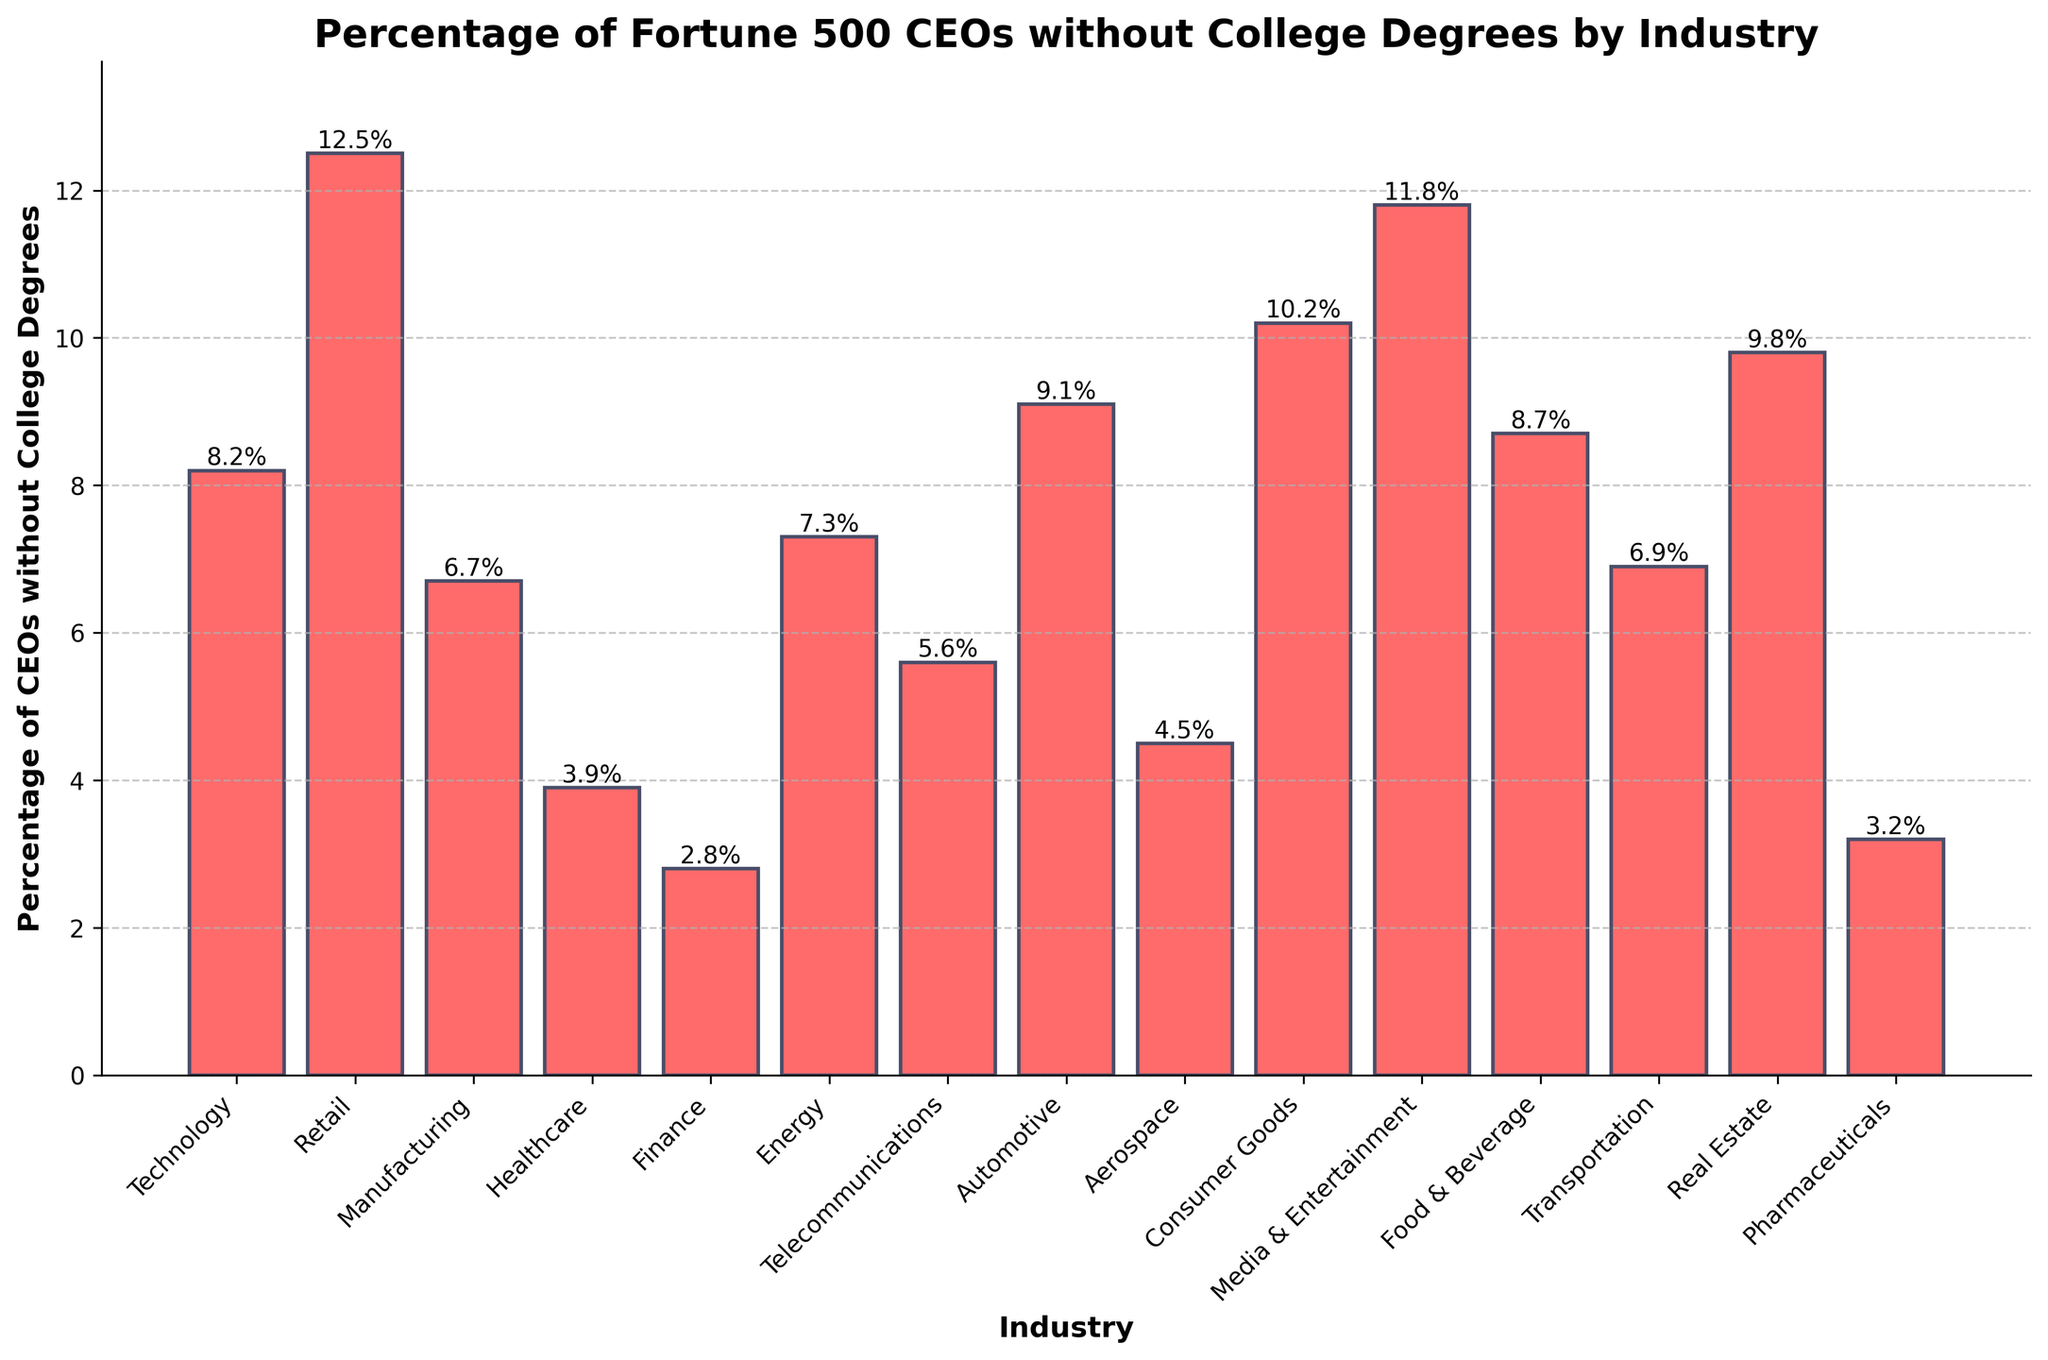What is the industry with the highest percentage of Fortune 500 CEOs without college degrees? The industry with the highest bar represents the industry with the highest percentage. By looking at the height of the bars, Retail has the highest percentage.
Answer: Retail Which industry has the lowest percentage of Fortune 500 CEOs without college degrees? The industry with the lowest bar represents the industry with the lowest percentage. The Finance industry has the lowest percentage.
Answer: Finance What is the percentage point difference between the Technology and Media & Entertainment industries regarding CEOs without college degrees? The percentage for Technology is 8.2%, and for Media & Entertainment, it is 11.8%. Subtract 8.2% from 11.8% to get the difference. 11.8% - 8.2% = 3.6%.
Answer: 3.6% Which industries have more than 10% of Fortune 500 CEOs without college degrees? Identify and list the industries with bars exceeding the 10% mark. From the graph, Media & Entertainment, Retail, Consumer Goods, and Real Estate exceed 10%.
Answer: Media & Entertainment, Retail, Consumer Goods, Real Estate Are there more industries above or below 7% in terms of the percentage of CEOs without college degrees? Count the number of industries with percentages above 7% and below 7%. There are 8 industries above 7% (Technology, Retail, Manufacturing, Energy, Automotive, Consumer Goods, Media & Entertainment, Food & Beverage) and 7 industries below 7% (Healthcare, Finance, Telecommunications, Aerospace, Transportation, Real Estate, Pharmaceuticals).
Answer: Above 7% Does the Consumer Goods industry have a higher or lower percentage of Fortune 500 CEOs without college degrees compared to the Automotive industry? Compare the bar heights of Consumer Goods (10.2%) and Automotive (9.1%). Consumer Goods has a higher percentage.
Answer: Higher Which three industries have the closest percentages of CEOs without college degrees and what are those percentages? Identify the industries with the closest bar heights. Transportation (6.9%), Energy (7.3%), and Technology (8.2%) have closely ranged percentages.
Answer: Transportation: 6.9%, Energy: 7.3%, Technology: 8.2% How much higher is the percentage of CEOs without college degrees in Retail compared to Pharmaceuticals? The percentage for Retail is 12.5%, and for Pharmaceuticals, it is 3.2%. Subtract 3.2% from 12.5% to find the difference. 12.5% - 3.2% = 9.3%.
Answer: 9.3% Which industry shows a percentage just below 5%? Look for a bar that tops out just below the 5% mark. The Healthcare industry's bar stands at 3.9%, which is just below 5%.
Answer: Healthcare 